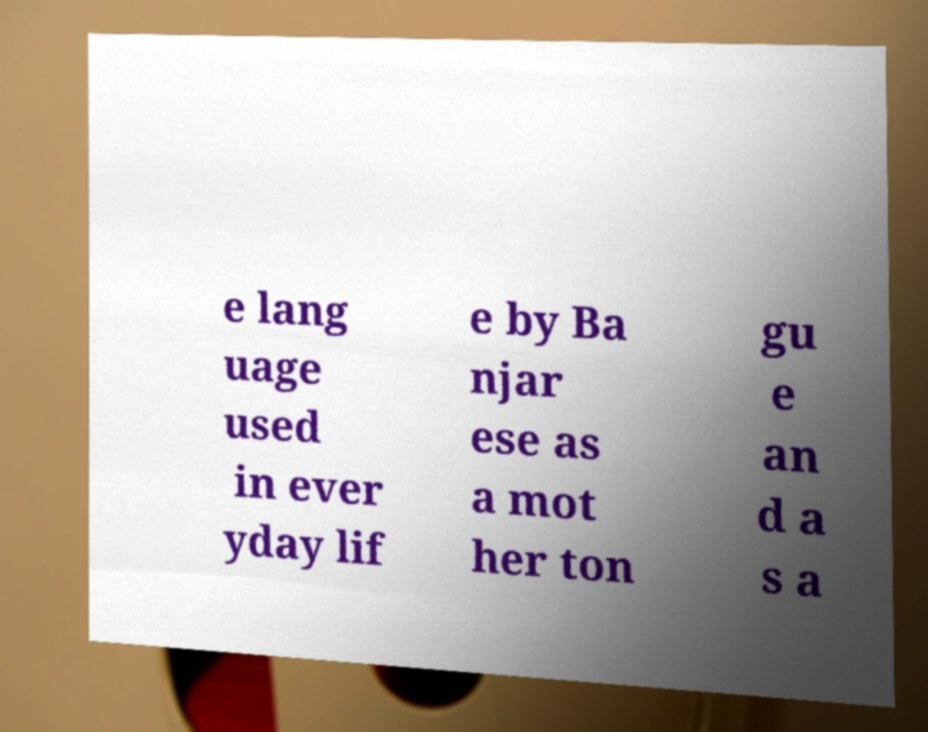What messages or text are displayed in this image? I need them in a readable, typed format. e lang uage used in ever yday lif e by Ba njar ese as a mot her ton gu e an d a s a 